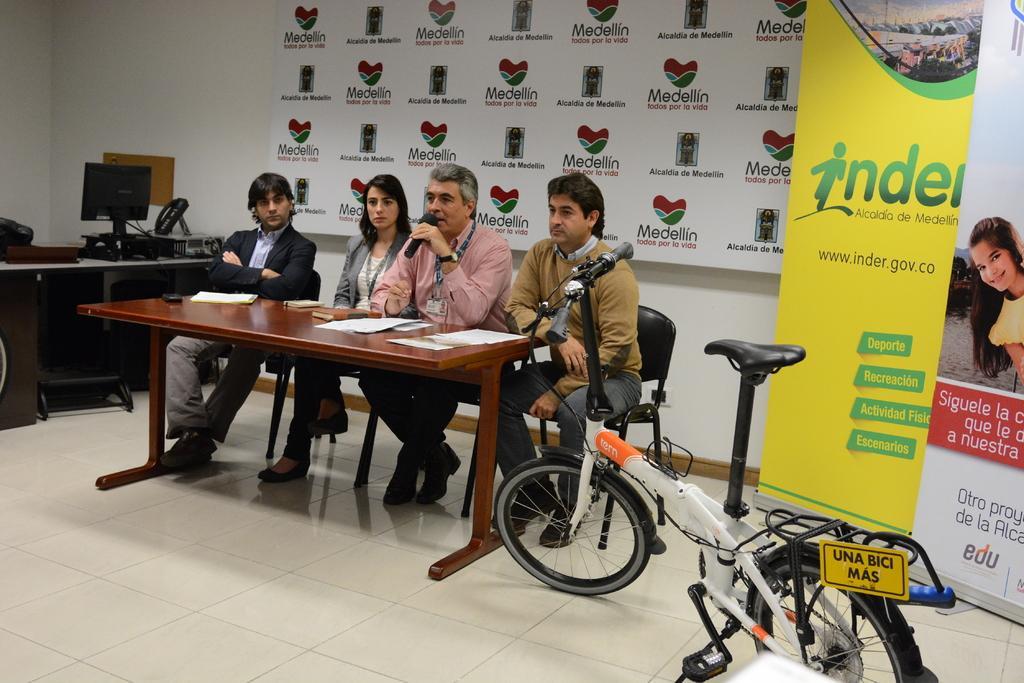Can you describe this image briefly? On the background we can see a wall,flexi and a hoarding board. This is a bicycle. here we can see few persons sitting on the chairs in front of a table and on the table we can see papers. he is holding a mike in his hand. At the left side of the picture we can see a table and a monitor on it. this is a floor. 